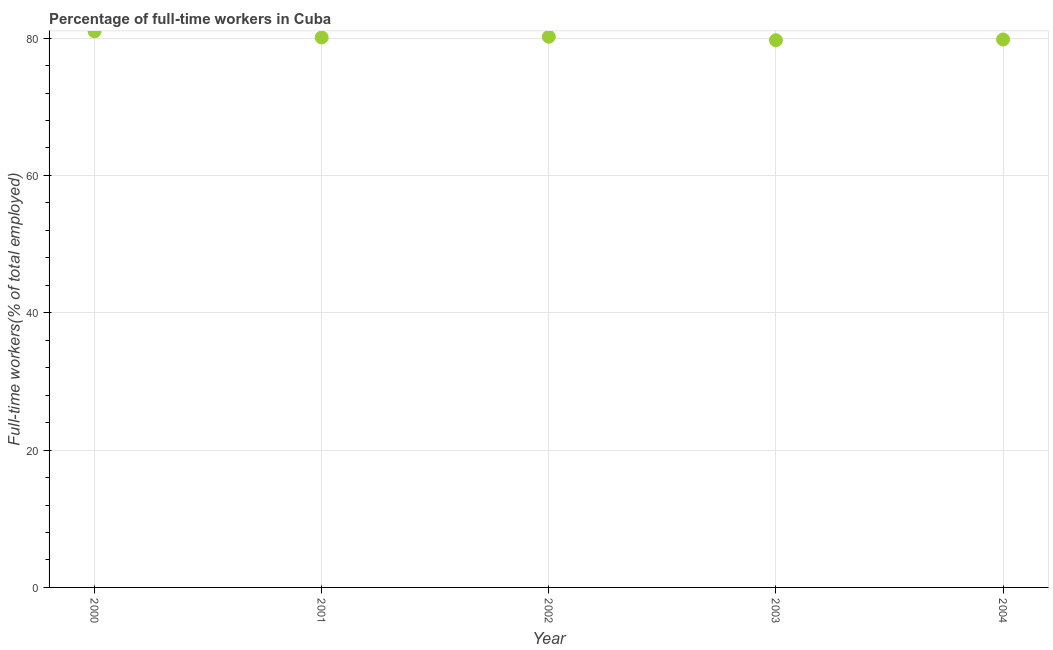What is the percentage of full-time workers in 2001?
Offer a very short reply. 80.1. Across all years, what is the maximum percentage of full-time workers?
Offer a very short reply. 81. Across all years, what is the minimum percentage of full-time workers?
Offer a terse response. 79.7. In which year was the percentage of full-time workers maximum?
Ensure brevity in your answer.  2000. In which year was the percentage of full-time workers minimum?
Provide a short and direct response. 2003. What is the sum of the percentage of full-time workers?
Your answer should be compact. 400.8. What is the difference between the percentage of full-time workers in 2000 and 2003?
Your answer should be very brief. 1.3. What is the average percentage of full-time workers per year?
Your response must be concise. 80.16. What is the median percentage of full-time workers?
Your response must be concise. 80.1. Do a majority of the years between 2000 and 2002 (inclusive) have percentage of full-time workers greater than 20 %?
Give a very brief answer. Yes. What is the ratio of the percentage of full-time workers in 2000 to that in 2001?
Your answer should be very brief. 1.01. Is the percentage of full-time workers in 2002 less than that in 2004?
Your answer should be compact. No. Is the difference between the percentage of full-time workers in 2001 and 2004 greater than the difference between any two years?
Provide a succinct answer. No. What is the difference between the highest and the second highest percentage of full-time workers?
Make the answer very short. 0.8. Is the sum of the percentage of full-time workers in 2001 and 2003 greater than the maximum percentage of full-time workers across all years?
Ensure brevity in your answer.  Yes. What is the difference between the highest and the lowest percentage of full-time workers?
Keep it short and to the point. 1.3. In how many years, is the percentage of full-time workers greater than the average percentage of full-time workers taken over all years?
Provide a short and direct response. 2. Are the values on the major ticks of Y-axis written in scientific E-notation?
Your answer should be very brief. No. Does the graph contain any zero values?
Provide a succinct answer. No. Does the graph contain grids?
Give a very brief answer. Yes. What is the title of the graph?
Your answer should be very brief. Percentage of full-time workers in Cuba. What is the label or title of the X-axis?
Provide a succinct answer. Year. What is the label or title of the Y-axis?
Ensure brevity in your answer.  Full-time workers(% of total employed). What is the Full-time workers(% of total employed) in 2000?
Your answer should be compact. 81. What is the Full-time workers(% of total employed) in 2001?
Provide a succinct answer. 80.1. What is the Full-time workers(% of total employed) in 2002?
Your answer should be compact. 80.2. What is the Full-time workers(% of total employed) in 2003?
Provide a succinct answer. 79.7. What is the Full-time workers(% of total employed) in 2004?
Your response must be concise. 79.8. What is the difference between the Full-time workers(% of total employed) in 2000 and 2001?
Your response must be concise. 0.9. What is the difference between the Full-time workers(% of total employed) in 2000 and 2004?
Offer a very short reply. 1.2. What is the difference between the Full-time workers(% of total employed) in 2001 and 2002?
Ensure brevity in your answer.  -0.1. What is the difference between the Full-time workers(% of total employed) in 2001 and 2003?
Offer a very short reply. 0.4. What is the difference between the Full-time workers(% of total employed) in 2002 and 2003?
Give a very brief answer. 0.5. What is the difference between the Full-time workers(% of total employed) in 2002 and 2004?
Ensure brevity in your answer.  0.4. What is the difference between the Full-time workers(% of total employed) in 2003 and 2004?
Ensure brevity in your answer.  -0.1. What is the ratio of the Full-time workers(% of total employed) in 2000 to that in 2001?
Your answer should be very brief. 1.01. What is the ratio of the Full-time workers(% of total employed) in 2000 to that in 2003?
Provide a short and direct response. 1.02. What is the ratio of the Full-time workers(% of total employed) in 2001 to that in 2002?
Keep it short and to the point. 1. What is the ratio of the Full-time workers(% of total employed) in 2002 to that in 2004?
Your response must be concise. 1. 